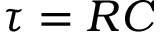Convert formula to latex. <formula><loc_0><loc_0><loc_500><loc_500>\tau = R C</formula> 